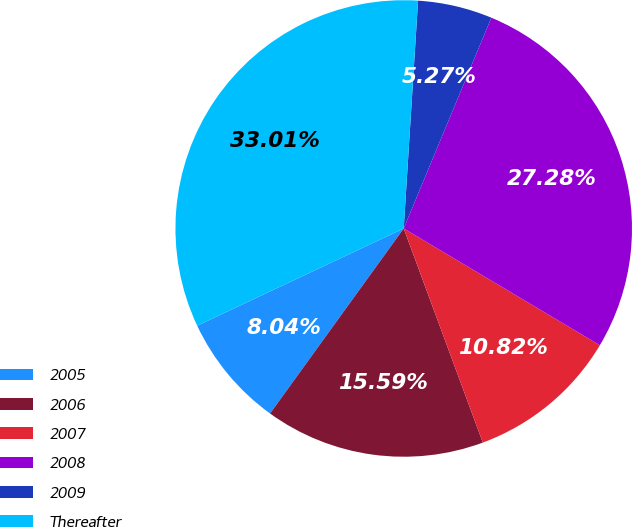<chart> <loc_0><loc_0><loc_500><loc_500><pie_chart><fcel>2005<fcel>2006<fcel>2007<fcel>2008<fcel>2009<fcel>Thereafter<nl><fcel>8.04%<fcel>15.59%<fcel>10.82%<fcel>27.28%<fcel>5.27%<fcel>33.01%<nl></chart> 